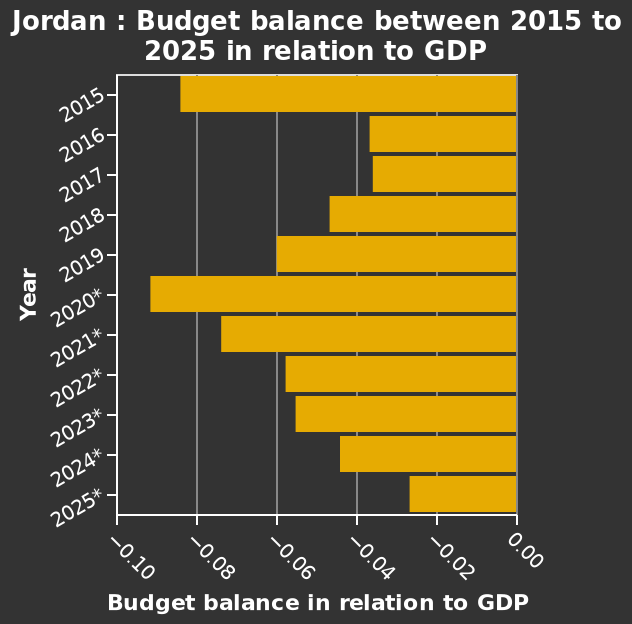<image>
What is the projected value for the budget balance in 2025? The projected value for the budget balance in 2025 is around -0.02. What is the name of the bar diagram?  The bar diagram is named Jordan. 